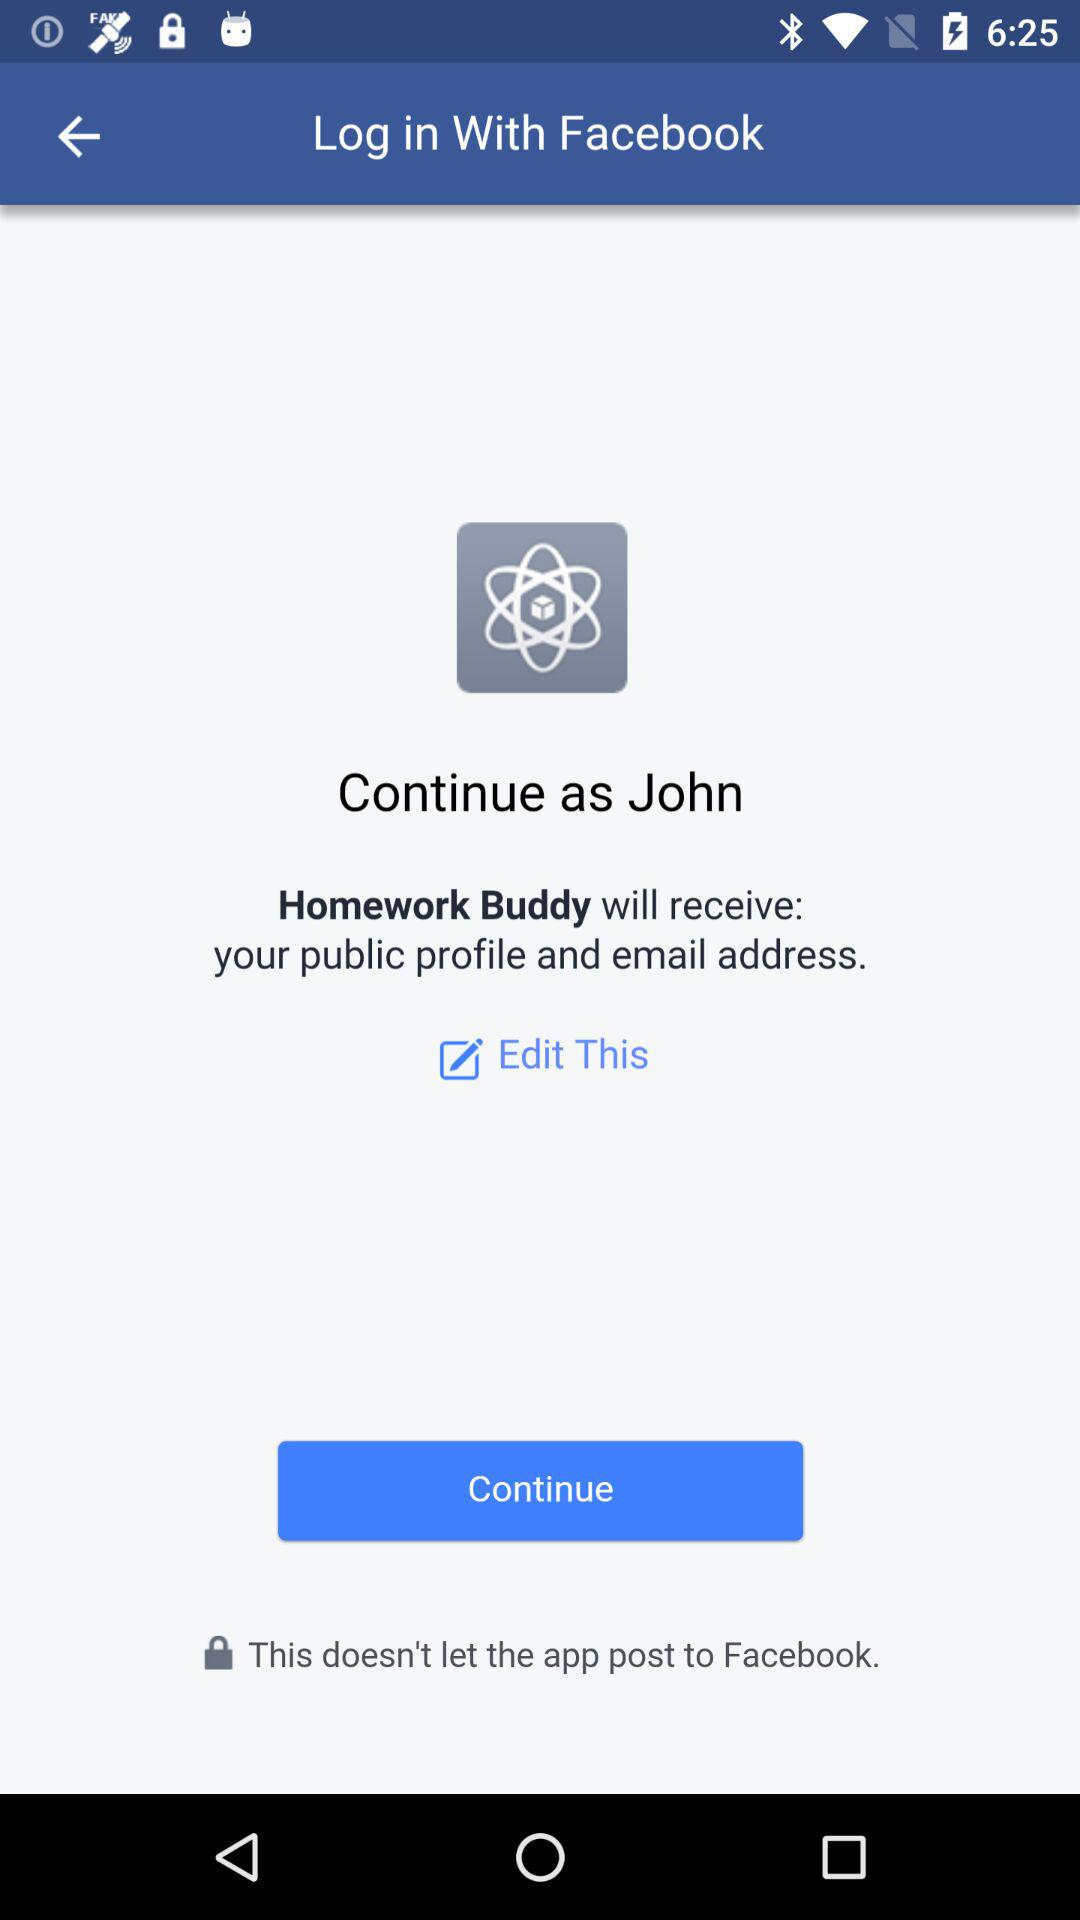What is the name of the user? The name of the user is John. 